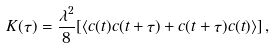Convert formula to latex. <formula><loc_0><loc_0><loc_500><loc_500>K ( \tau ) = \frac { \lambda ^ { 2 } } { 8 } [ \langle c ( t ) c ( t + \tau ) + c ( t + \tau ) c ( t ) \rangle ] \, ,</formula> 